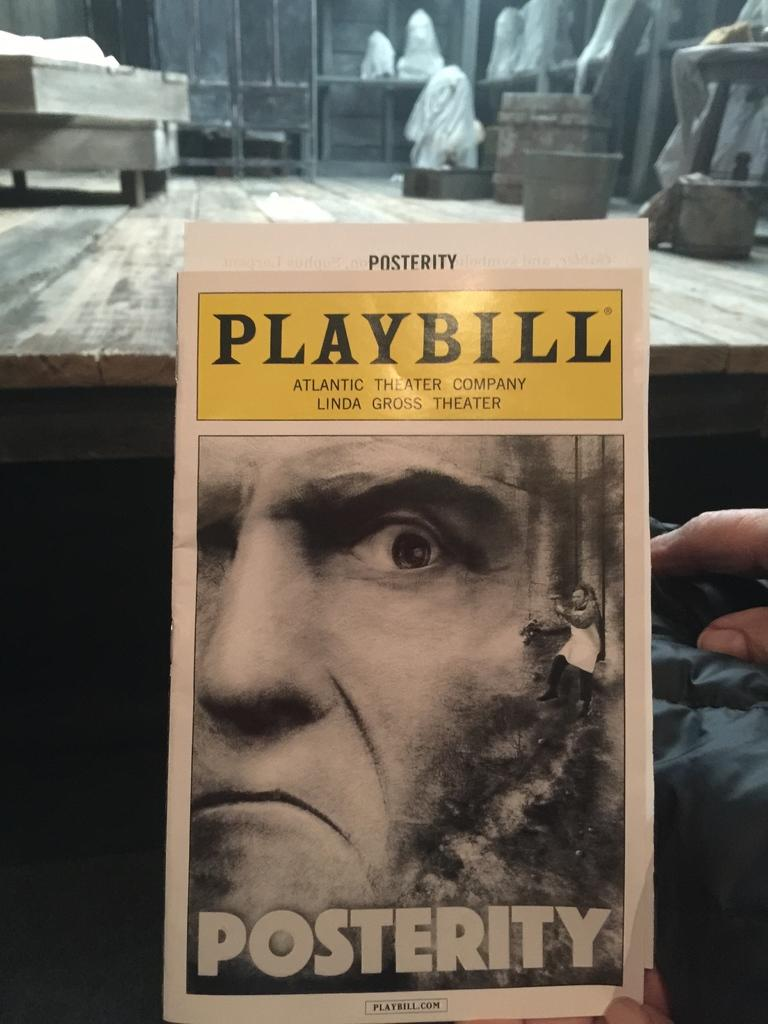<image>
Provide a brief description of the given image. A playbill for the show Posterity is being held by someone. 